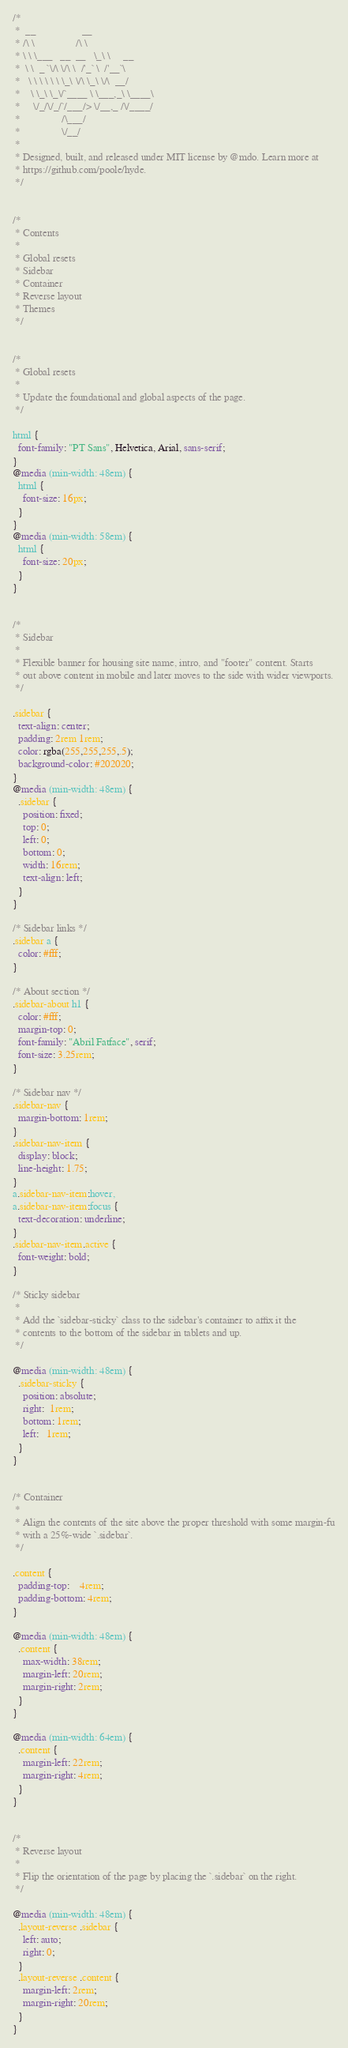Convert code to text. <code><loc_0><loc_0><loc_500><loc_500><_CSS_>/*
 *  __                  __
 * /\ \                /\ \
 * \ \ \___   __  __   \_\ \     __
 *  \ \  _ `\/\ \/\ \  /'_` \  /'__`\
 *   \ \ \ \ \ \ \_\ \/\ \_\ \/\  __/
 *    \ \_\ \_\/`____ \ \___,_\ \____\
 *     \/_/\/_/`/___/> \/__,_ /\/____/
 *                /\___/
 *                \/__/
 *
 * Designed, built, and released under MIT license by @mdo. Learn more at
 * https://github.com/poole/hyde.
 */


/*
 * Contents
 *
 * Global resets
 * Sidebar
 * Container
 * Reverse layout
 * Themes
 */


/*
 * Global resets
 *
 * Update the foundational and global aspects of the page.
 */

html {
  font-family: "PT Sans", Helvetica, Arial, sans-serif;
}
@media (min-width: 48em) {
  html {
    font-size: 16px;
  }
}
@media (min-width: 58em) {
  html {
    font-size: 20px;
  }
}


/*
 * Sidebar
 *
 * Flexible banner for housing site name, intro, and "footer" content. Starts
 * out above content in mobile and later moves to the side with wider viewports.
 */

.sidebar {
  text-align: center;
  padding: 2rem 1rem;
  color: rgba(255,255,255,.5);
  background-color: #202020;
}
@media (min-width: 48em) {
  .sidebar {
    position: fixed;
    top: 0;
    left: 0;
    bottom: 0;
    width: 16rem;
    text-align: left;
  }
}

/* Sidebar links */
.sidebar a {
  color: #fff;
}

/* About section */
.sidebar-about h1 {
  color: #fff;
  margin-top: 0;
  font-family: "Abril Fatface", serif;
  font-size: 3.25rem;
}

/* Sidebar nav */
.sidebar-nav {
  margin-bottom: 1rem;
}
.sidebar-nav-item {
  display: block;
  line-height: 1.75;
}
a.sidebar-nav-item:hover,
a.sidebar-nav-item:focus {
  text-decoration: underline;
}
.sidebar-nav-item.active {
  font-weight: bold;
}

/* Sticky sidebar
 *
 * Add the `sidebar-sticky` class to the sidebar's container to affix it the
 * contents to the bottom of the sidebar in tablets and up.
 */

@media (min-width: 48em) {
  .sidebar-sticky {
    position: absolute;
    right:  1rem;
    bottom: 1rem;
    left:   1rem;
  }
}


/* Container
 *
 * Align the contents of the site above the proper threshold with some margin-fu
 * with a 25%-wide `.sidebar`.
 */

.content {
  padding-top:    4rem;
  padding-bottom: 4rem;
}

@media (min-width: 48em) {
  .content {
    max-width: 38rem;
    margin-left: 20rem;
    margin-right: 2rem;
  }
}

@media (min-width: 64em) {
  .content {
    margin-left: 22rem;
    margin-right: 4rem;
  }
}


/*
 * Reverse layout
 *
 * Flip the orientation of the page by placing the `.sidebar` on the right.
 */

@media (min-width: 48em) {
  .layout-reverse .sidebar {
    left: auto;
    right: 0;
  }
  .layout-reverse .content {
    margin-left: 2rem;
    margin-right: 20rem;
  }
}
</code> 